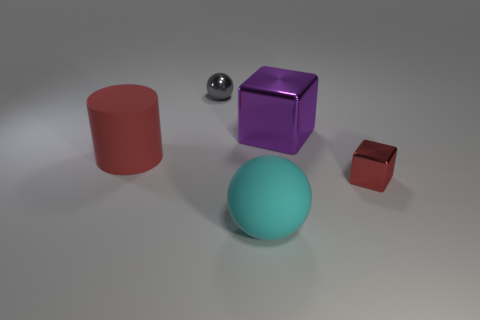There is a large thing left of the big object in front of the rubber cylinder; what number of tiny gray spheres are in front of it?
Your answer should be very brief. 0. How many rubber objects are either red blocks or gray spheres?
Give a very brief answer. 0. What color is the object that is left of the big cyan matte sphere and in front of the gray shiny ball?
Provide a succinct answer. Red. There is a metallic thing in front of the red rubber cylinder; does it have the same size as the big purple metallic block?
Make the answer very short. No. How many objects are objects that are behind the cyan ball or spheres?
Make the answer very short. 5. Is there a red cylinder of the same size as the cyan rubber thing?
Offer a terse response. Yes. There is a cylinder that is the same size as the cyan matte sphere; what is it made of?
Your answer should be very brief. Rubber. What is the shape of the thing that is both in front of the large red matte thing and on the right side of the big sphere?
Provide a succinct answer. Cube. There is a block that is to the right of the big purple cube; what color is it?
Your answer should be compact. Red. There is a thing that is right of the metallic ball and on the left side of the purple metallic object; what is its size?
Provide a succinct answer. Large. 